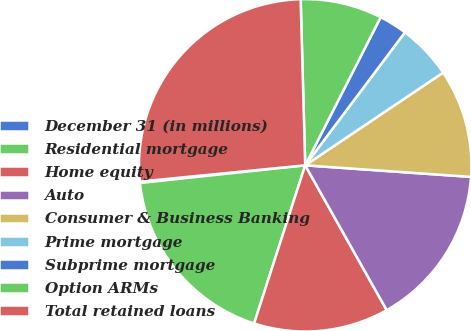Convert chart. <chart><loc_0><loc_0><loc_500><loc_500><pie_chart><fcel>December 31 (in millions)<fcel>Residential mortgage<fcel>Home equity<fcel>Auto<fcel>Consumer & Business Banking<fcel>Prime mortgage<fcel>Subprime mortgage<fcel>Option ARMs<fcel>Total retained loans<nl><fcel>0.14%<fcel>18.33%<fcel>13.13%<fcel>15.73%<fcel>10.53%<fcel>5.34%<fcel>2.74%<fcel>7.94%<fcel>26.12%<nl></chart> 